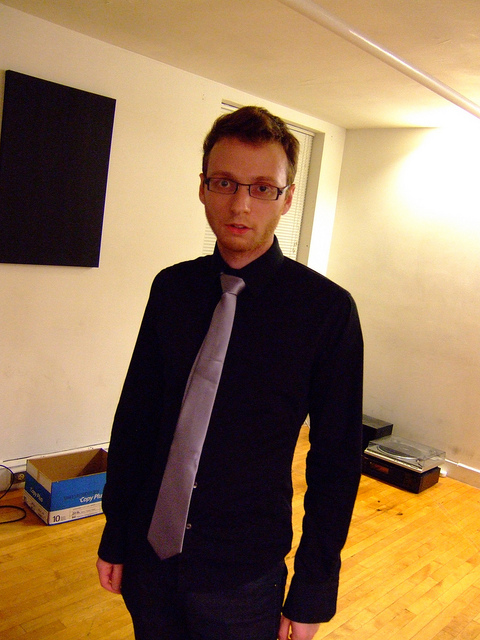The empty space seems quite vast. How might one go about optimizing it for a comfortable living arrangement? Given the open space, one could optimize it for comfort by strategically placing furniture to create distinct living areas. For example, a sofa and coffee table can establish a cozy lounge area, while a dining table and chairs can define the eating space. Utilizing rugs can also help to delineate these zones and add a warm touch to the room. 